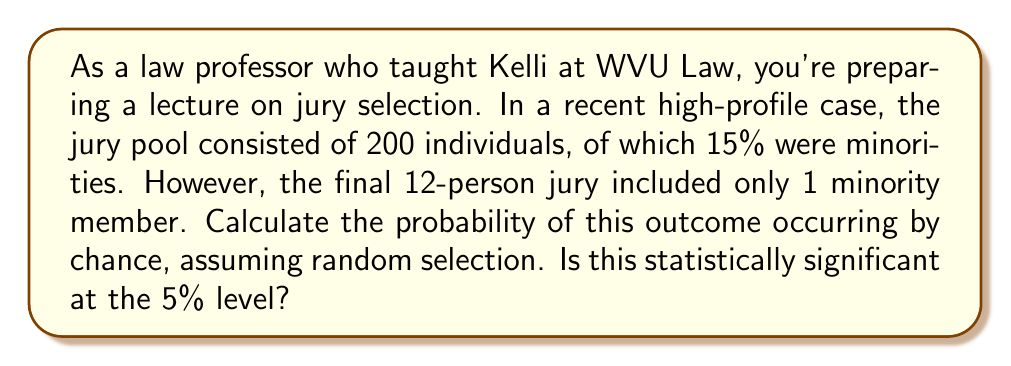Could you help me with this problem? To analyze the statistical significance of this jury selection, we'll use the binomial distribution and perform a hypothesis test.

1) First, let's define our variables:
   $n = 12$ (size of the jury)
   $p = 0.15$ (proportion of minorities in the jury pool)
   $X = 1$ (number of minorities in the actual jury)

2) Our null hypothesis is that the selection was random. The alternative hypothesis is that the selection was biased against minorities.

3) Under the null hypothesis, $X$ follows a binomial distribution with parameters $n$ and $p$. We want to calculate $P(X \leq 1)$.

4) The probability mass function for the binomial distribution is:

   $$P(X = k) = \binom{n}{k} p^k (1-p)^{n-k}$$

5) We need to calculate $P(X = 0) + P(X = 1)$:

   $$P(X = 0) = \binom{12}{0} (0.15)^0 (0.85)^{12} = 0.1422$$
   $$P(X = 1) = \binom{12}{1} (0.15)^1 (0.85)^{11} = 0.3012$$

6) Therefore, $P(X \leq 1) = 0.1422 + 0.3012 = 0.4434$

7) This p-value (0.4434) is greater than the significance level (0.05), so we fail to reject the null hypothesis.
Answer: The probability of having 1 or fewer minority members in a randomly selected 12-person jury from this pool is 0.4434 or 44.34%. This is not statistically significant at the 5% level, so we cannot conclude that the jury selection process was biased based solely on this data. 